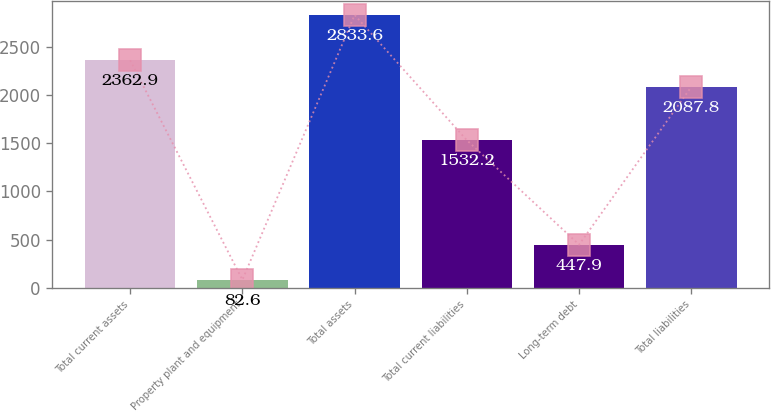Convert chart. <chart><loc_0><loc_0><loc_500><loc_500><bar_chart><fcel>Total current assets<fcel>Property plant and equipment<fcel>Total assets<fcel>Total current liabilities<fcel>Long-term debt<fcel>Total liabilities<nl><fcel>2362.9<fcel>82.6<fcel>2833.6<fcel>1532.2<fcel>447.9<fcel>2087.8<nl></chart> 